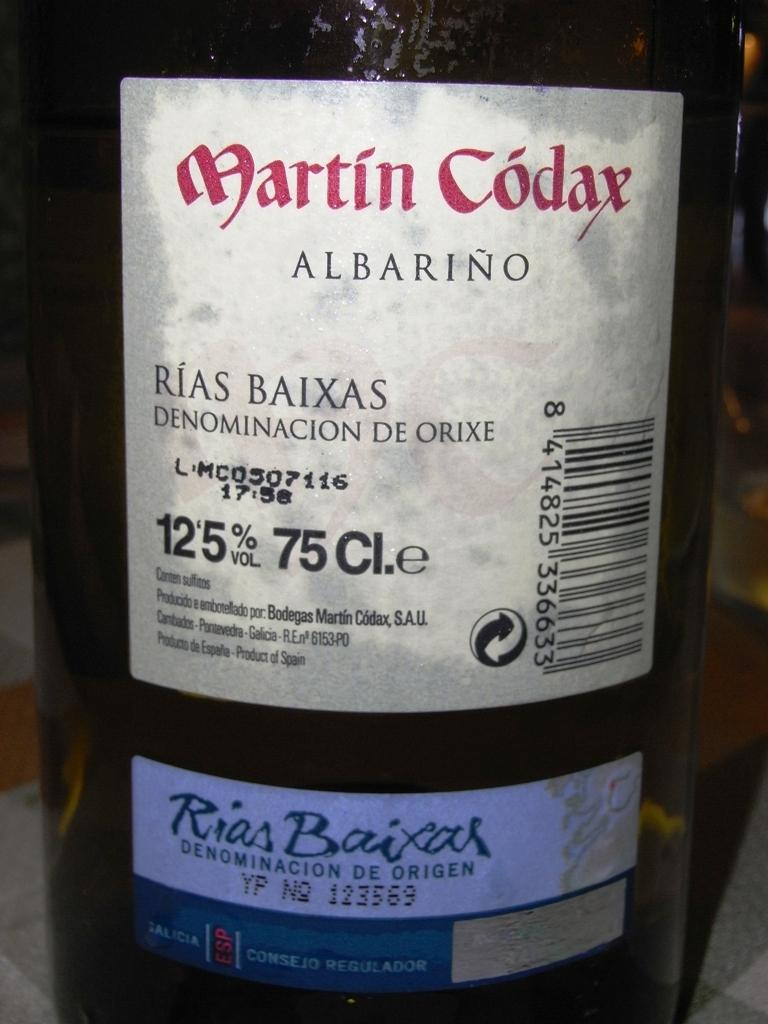<image>
Create a compact narrative representing the image presented. A bottle of Martin Codax Albarino wine with 12.5% alcohol volume 